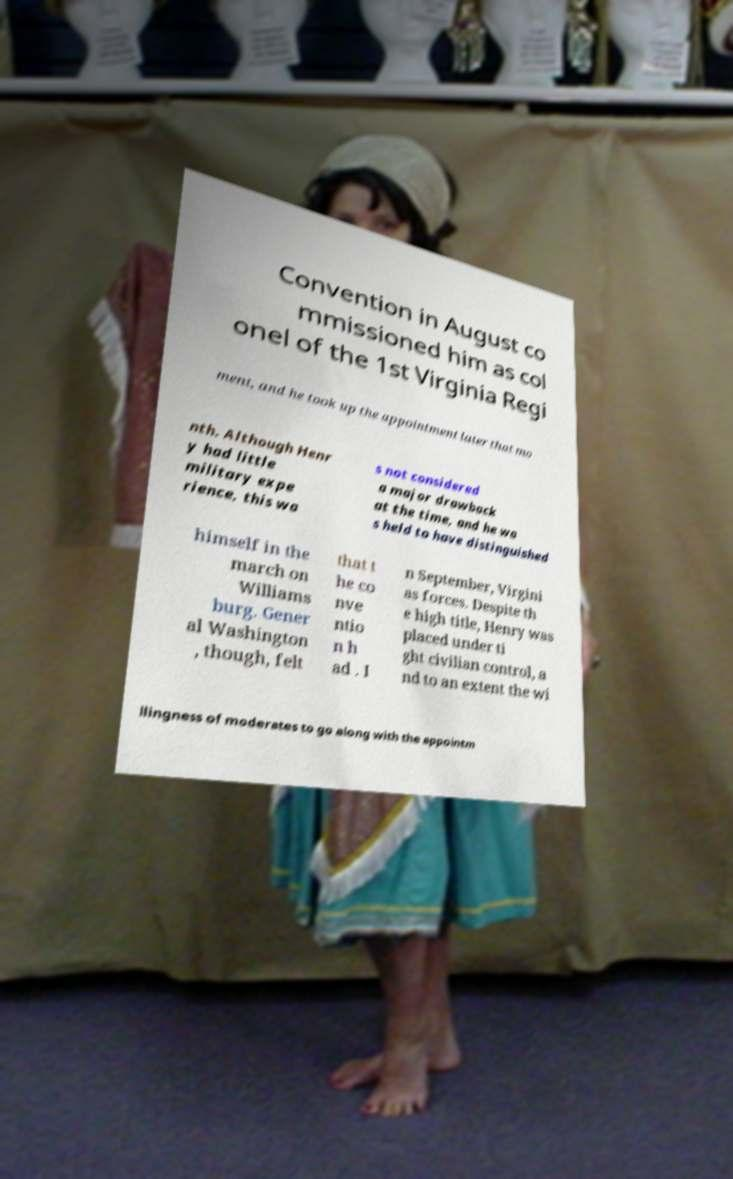I need the written content from this picture converted into text. Can you do that? Convention in August co mmissioned him as col onel of the 1st Virginia Regi ment, and he took up the appointment later that mo nth. Although Henr y had little military expe rience, this wa s not considered a major drawback at the time, and he wa s held to have distinguished himself in the march on Williams burg. Gener al Washington , though, felt that t he co nve ntio n h ad . I n September, Virgini as forces. Despite th e high title, Henry was placed under ti ght civilian control, a nd to an extent the wi llingness of moderates to go along with the appointm 